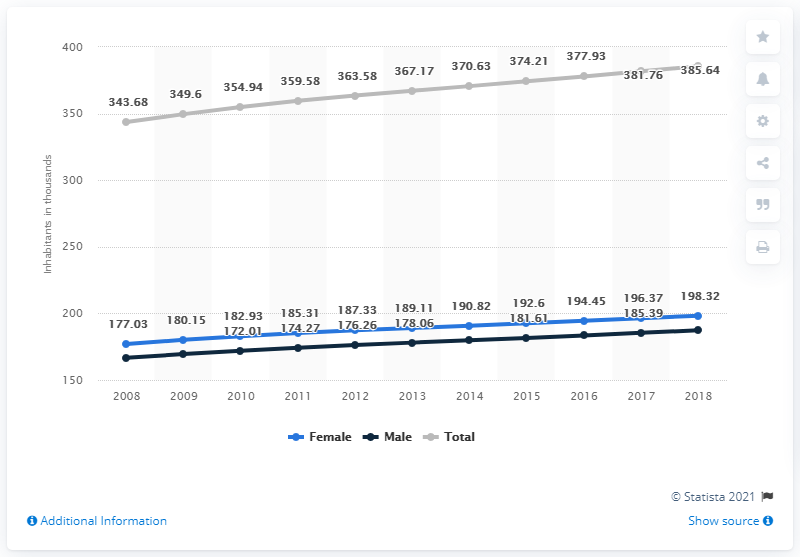What's the value of total population increased from 2016 to 2018?
 7.71 